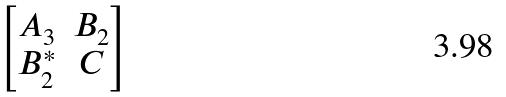Convert formula to latex. <formula><loc_0><loc_0><loc_500><loc_500>\begin{bmatrix} A _ { 3 } & B _ { 2 } \\ B _ { 2 } ^ { * } & C \end{bmatrix}</formula> 